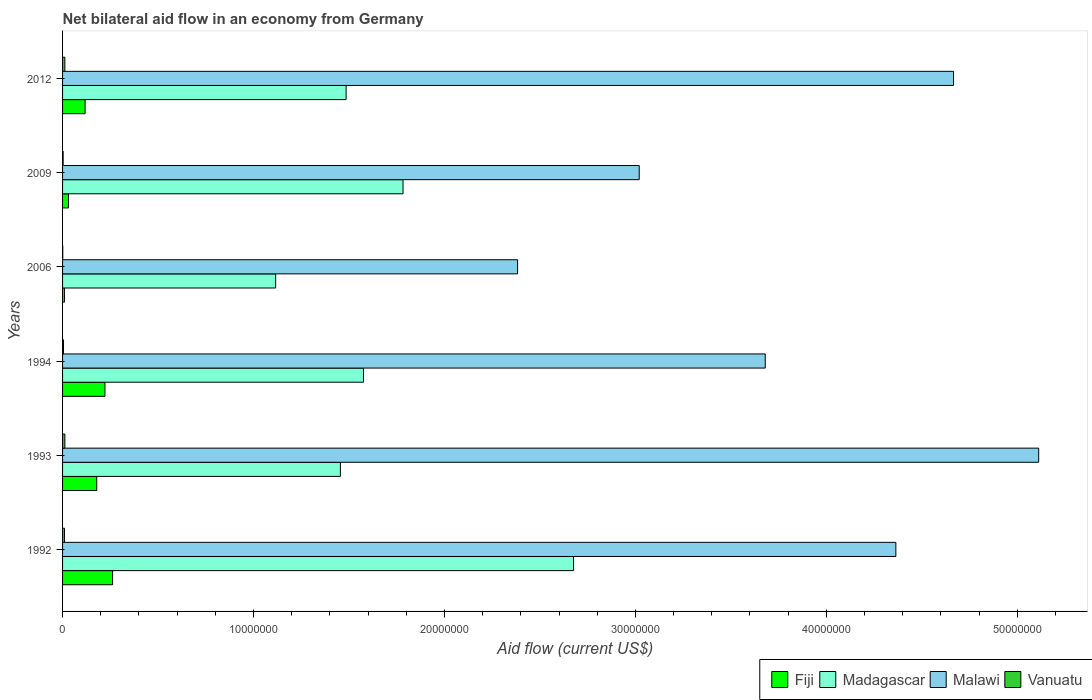How many different coloured bars are there?
Your answer should be compact. 4. How many bars are there on the 3rd tick from the bottom?
Your answer should be compact. 4. What is the net bilateral aid flow in Malawi in 1993?
Your response must be concise. 5.11e+07. Across all years, what is the maximum net bilateral aid flow in Vanuatu?
Keep it short and to the point. 1.20e+05. Across all years, what is the minimum net bilateral aid flow in Fiji?
Your response must be concise. 1.00e+05. In which year was the net bilateral aid flow in Fiji minimum?
Your answer should be very brief. 2006. What is the total net bilateral aid flow in Madagascar in the graph?
Give a very brief answer. 1.01e+08. What is the difference between the net bilateral aid flow in Madagascar in 1992 and that in 2006?
Make the answer very short. 1.56e+07. What is the difference between the net bilateral aid flow in Malawi in 2006 and the net bilateral aid flow in Fiji in 1994?
Ensure brevity in your answer.  2.16e+07. What is the average net bilateral aid flow in Malawi per year?
Your answer should be compact. 3.87e+07. In the year 1993, what is the difference between the net bilateral aid flow in Malawi and net bilateral aid flow in Vanuatu?
Your response must be concise. 5.10e+07. What is the ratio of the net bilateral aid flow in Fiji in 1993 to that in 2012?
Provide a short and direct response. 1.52. What is the difference between the highest and the lowest net bilateral aid flow in Malawi?
Provide a succinct answer. 2.73e+07. In how many years, is the net bilateral aid flow in Madagascar greater than the average net bilateral aid flow in Madagascar taken over all years?
Offer a very short reply. 2. What does the 2nd bar from the top in 2009 represents?
Offer a very short reply. Malawi. What does the 4th bar from the bottom in 1993 represents?
Provide a succinct answer. Vanuatu. How many bars are there?
Keep it short and to the point. 24. Are all the bars in the graph horizontal?
Offer a very short reply. Yes. Are the values on the major ticks of X-axis written in scientific E-notation?
Give a very brief answer. No. Does the graph contain grids?
Your answer should be very brief. No. Where does the legend appear in the graph?
Your answer should be compact. Bottom right. How many legend labels are there?
Provide a succinct answer. 4. What is the title of the graph?
Ensure brevity in your answer.  Net bilateral aid flow in an economy from Germany. Does "Zambia" appear as one of the legend labels in the graph?
Offer a very short reply. No. What is the label or title of the Y-axis?
Keep it short and to the point. Years. What is the Aid flow (current US$) in Fiji in 1992?
Make the answer very short. 2.62e+06. What is the Aid flow (current US$) of Madagascar in 1992?
Your response must be concise. 2.68e+07. What is the Aid flow (current US$) of Malawi in 1992?
Keep it short and to the point. 4.36e+07. What is the Aid flow (current US$) of Vanuatu in 1992?
Keep it short and to the point. 1.00e+05. What is the Aid flow (current US$) of Fiji in 1993?
Your response must be concise. 1.79e+06. What is the Aid flow (current US$) in Madagascar in 1993?
Your answer should be very brief. 1.46e+07. What is the Aid flow (current US$) in Malawi in 1993?
Make the answer very short. 5.11e+07. What is the Aid flow (current US$) of Fiji in 1994?
Give a very brief answer. 2.22e+06. What is the Aid flow (current US$) of Madagascar in 1994?
Make the answer very short. 1.58e+07. What is the Aid flow (current US$) of Malawi in 1994?
Make the answer very short. 3.68e+07. What is the Aid flow (current US$) of Vanuatu in 1994?
Your answer should be compact. 5.00e+04. What is the Aid flow (current US$) of Fiji in 2006?
Offer a terse response. 1.00e+05. What is the Aid flow (current US$) of Madagascar in 2006?
Provide a succinct answer. 1.12e+07. What is the Aid flow (current US$) in Malawi in 2006?
Keep it short and to the point. 2.38e+07. What is the Aid flow (current US$) in Vanuatu in 2006?
Make the answer very short. 10000. What is the Aid flow (current US$) of Fiji in 2009?
Offer a very short reply. 3.10e+05. What is the Aid flow (current US$) of Madagascar in 2009?
Provide a succinct answer. 1.78e+07. What is the Aid flow (current US$) in Malawi in 2009?
Give a very brief answer. 3.02e+07. What is the Aid flow (current US$) of Fiji in 2012?
Offer a terse response. 1.18e+06. What is the Aid flow (current US$) in Madagascar in 2012?
Your response must be concise. 1.48e+07. What is the Aid flow (current US$) in Malawi in 2012?
Make the answer very short. 4.67e+07. Across all years, what is the maximum Aid flow (current US$) in Fiji?
Provide a short and direct response. 2.62e+06. Across all years, what is the maximum Aid flow (current US$) in Madagascar?
Offer a terse response. 2.68e+07. Across all years, what is the maximum Aid flow (current US$) in Malawi?
Provide a succinct answer. 5.11e+07. Across all years, what is the maximum Aid flow (current US$) of Vanuatu?
Provide a short and direct response. 1.20e+05. Across all years, what is the minimum Aid flow (current US$) of Madagascar?
Keep it short and to the point. 1.12e+07. Across all years, what is the minimum Aid flow (current US$) of Malawi?
Provide a short and direct response. 2.38e+07. Across all years, what is the minimum Aid flow (current US$) in Vanuatu?
Provide a succinct answer. 10000. What is the total Aid flow (current US$) of Fiji in the graph?
Your answer should be compact. 8.22e+06. What is the total Aid flow (current US$) of Madagascar in the graph?
Offer a very short reply. 1.01e+08. What is the total Aid flow (current US$) of Malawi in the graph?
Your answer should be compact. 2.32e+08. What is the total Aid flow (current US$) in Vanuatu in the graph?
Ensure brevity in your answer.  4.30e+05. What is the difference between the Aid flow (current US$) of Fiji in 1992 and that in 1993?
Provide a short and direct response. 8.30e+05. What is the difference between the Aid flow (current US$) in Madagascar in 1992 and that in 1993?
Provide a succinct answer. 1.22e+07. What is the difference between the Aid flow (current US$) of Malawi in 1992 and that in 1993?
Provide a short and direct response. -7.48e+06. What is the difference between the Aid flow (current US$) of Vanuatu in 1992 and that in 1993?
Your answer should be compact. -2.00e+04. What is the difference between the Aid flow (current US$) of Fiji in 1992 and that in 1994?
Provide a succinct answer. 4.00e+05. What is the difference between the Aid flow (current US$) in Madagascar in 1992 and that in 1994?
Make the answer very short. 1.10e+07. What is the difference between the Aid flow (current US$) in Malawi in 1992 and that in 1994?
Provide a succinct answer. 6.84e+06. What is the difference between the Aid flow (current US$) of Vanuatu in 1992 and that in 1994?
Provide a succinct answer. 5.00e+04. What is the difference between the Aid flow (current US$) in Fiji in 1992 and that in 2006?
Give a very brief answer. 2.52e+06. What is the difference between the Aid flow (current US$) of Madagascar in 1992 and that in 2006?
Offer a terse response. 1.56e+07. What is the difference between the Aid flow (current US$) in Malawi in 1992 and that in 2006?
Your answer should be compact. 1.98e+07. What is the difference between the Aid flow (current US$) of Fiji in 1992 and that in 2009?
Your answer should be very brief. 2.31e+06. What is the difference between the Aid flow (current US$) in Madagascar in 1992 and that in 2009?
Your answer should be compact. 8.93e+06. What is the difference between the Aid flow (current US$) in Malawi in 1992 and that in 2009?
Ensure brevity in your answer.  1.34e+07. What is the difference between the Aid flow (current US$) in Vanuatu in 1992 and that in 2009?
Give a very brief answer. 7.00e+04. What is the difference between the Aid flow (current US$) in Fiji in 1992 and that in 2012?
Provide a short and direct response. 1.44e+06. What is the difference between the Aid flow (current US$) in Madagascar in 1992 and that in 2012?
Provide a succinct answer. 1.19e+07. What is the difference between the Aid flow (current US$) of Malawi in 1992 and that in 2012?
Offer a terse response. -3.02e+06. What is the difference between the Aid flow (current US$) in Fiji in 1993 and that in 1994?
Make the answer very short. -4.30e+05. What is the difference between the Aid flow (current US$) in Madagascar in 1993 and that in 1994?
Provide a short and direct response. -1.21e+06. What is the difference between the Aid flow (current US$) of Malawi in 1993 and that in 1994?
Keep it short and to the point. 1.43e+07. What is the difference between the Aid flow (current US$) of Vanuatu in 1993 and that in 1994?
Give a very brief answer. 7.00e+04. What is the difference between the Aid flow (current US$) in Fiji in 1993 and that in 2006?
Your response must be concise. 1.69e+06. What is the difference between the Aid flow (current US$) of Madagascar in 1993 and that in 2006?
Ensure brevity in your answer.  3.39e+06. What is the difference between the Aid flow (current US$) of Malawi in 1993 and that in 2006?
Your response must be concise. 2.73e+07. What is the difference between the Aid flow (current US$) of Vanuatu in 1993 and that in 2006?
Ensure brevity in your answer.  1.10e+05. What is the difference between the Aid flow (current US$) of Fiji in 1993 and that in 2009?
Your answer should be compact. 1.48e+06. What is the difference between the Aid flow (current US$) in Madagascar in 1993 and that in 2009?
Give a very brief answer. -3.28e+06. What is the difference between the Aid flow (current US$) in Malawi in 1993 and that in 2009?
Ensure brevity in your answer.  2.09e+07. What is the difference between the Aid flow (current US$) in Fiji in 1993 and that in 2012?
Provide a short and direct response. 6.10e+05. What is the difference between the Aid flow (current US$) of Malawi in 1993 and that in 2012?
Your answer should be very brief. 4.46e+06. What is the difference between the Aid flow (current US$) of Vanuatu in 1993 and that in 2012?
Provide a short and direct response. 0. What is the difference between the Aid flow (current US$) of Fiji in 1994 and that in 2006?
Make the answer very short. 2.12e+06. What is the difference between the Aid flow (current US$) of Madagascar in 1994 and that in 2006?
Your answer should be compact. 4.60e+06. What is the difference between the Aid flow (current US$) of Malawi in 1994 and that in 2006?
Keep it short and to the point. 1.30e+07. What is the difference between the Aid flow (current US$) in Vanuatu in 1994 and that in 2006?
Ensure brevity in your answer.  4.00e+04. What is the difference between the Aid flow (current US$) in Fiji in 1994 and that in 2009?
Provide a short and direct response. 1.91e+06. What is the difference between the Aid flow (current US$) in Madagascar in 1994 and that in 2009?
Give a very brief answer. -2.07e+06. What is the difference between the Aid flow (current US$) in Malawi in 1994 and that in 2009?
Keep it short and to the point. 6.60e+06. What is the difference between the Aid flow (current US$) of Vanuatu in 1994 and that in 2009?
Offer a very short reply. 2.00e+04. What is the difference between the Aid flow (current US$) of Fiji in 1994 and that in 2012?
Your response must be concise. 1.04e+06. What is the difference between the Aid flow (current US$) in Madagascar in 1994 and that in 2012?
Your answer should be compact. 9.10e+05. What is the difference between the Aid flow (current US$) of Malawi in 1994 and that in 2012?
Keep it short and to the point. -9.86e+06. What is the difference between the Aid flow (current US$) in Vanuatu in 1994 and that in 2012?
Provide a succinct answer. -7.00e+04. What is the difference between the Aid flow (current US$) of Madagascar in 2006 and that in 2009?
Make the answer very short. -6.67e+06. What is the difference between the Aid flow (current US$) of Malawi in 2006 and that in 2009?
Provide a short and direct response. -6.37e+06. What is the difference between the Aid flow (current US$) in Vanuatu in 2006 and that in 2009?
Make the answer very short. -2.00e+04. What is the difference between the Aid flow (current US$) in Fiji in 2006 and that in 2012?
Ensure brevity in your answer.  -1.08e+06. What is the difference between the Aid flow (current US$) of Madagascar in 2006 and that in 2012?
Your answer should be compact. -3.69e+06. What is the difference between the Aid flow (current US$) of Malawi in 2006 and that in 2012?
Ensure brevity in your answer.  -2.28e+07. What is the difference between the Aid flow (current US$) in Vanuatu in 2006 and that in 2012?
Give a very brief answer. -1.10e+05. What is the difference between the Aid flow (current US$) of Fiji in 2009 and that in 2012?
Give a very brief answer. -8.70e+05. What is the difference between the Aid flow (current US$) of Madagascar in 2009 and that in 2012?
Provide a succinct answer. 2.98e+06. What is the difference between the Aid flow (current US$) in Malawi in 2009 and that in 2012?
Your response must be concise. -1.65e+07. What is the difference between the Aid flow (current US$) of Vanuatu in 2009 and that in 2012?
Your answer should be compact. -9.00e+04. What is the difference between the Aid flow (current US$) in Fiji in 1992 and the Aid flow (current US$) in Madagascar in 1993?
Provide a succinct answer. -1.19e+07. What is the difference between the Aid flow (current US$) of Fiji in 1992 and the Aid flow (current US$) of Malawi in 1993?
Your answer should be very brief. -4.85e+07. What is the difference between the Aid flow (current US$) of Fiji in 1992 and the Aid flow (current US$) of Vanuatu in 1993?
Your answer should be compact. 2.50e+06. What is the difference between the Aid flow (current US$) in Madagascar in 1992 and the Aid flow (current US$) in Malawi in 1993?
Make the answer very short. -2.44e+07. What is the difference between the Aid flow (current US$) in Madagascar in 1992 and the Aid flow (current US$) in Vanuatu in 1993?
Ensure brevity in your answer.  2.66e+07. What is the difference between the Aid flow (current US$) in Malawi in 1992 and the Aid flow (current US$) in Vanuatu in 1993?
Offer a terse response. 4.35e+07. What is the difference between the Aid flow (current US$) in Fiji in 1992 and the Aid flow (current US$) in Madagascar in 1994?
Your answer should be very brief. -1.31e+07. What is the difference between the Aid flow (current US$) in Fiji in 1992 and the Aid flow (current US$) in Malawi in 1994?
Provide a short and direct response. -3.42e+07. What is the difference between the Aid flow (current US$) of Fiji in 1992 and the Aid flow (current US$) of Vanuatu in 1994?
Your answer should be very brief. 2.57e+06. What is the difference between the Aid flow (current US$) in Madagascar in 1992 and the Aid flow (current US$) in Malawi in 1994?
Ensure brevity in your answer.  -1.00e+07. What is the difference between the Aid flow (current US$) of Madagascar in 1992 and the Aid flow (current US$) of Vanuatu in 1994?
Provide a succinct answer. 2.67e+07. What is the difference between the Aid flow (current US$) in Malawi in 1992 and the Aid flow (current US$) in Vanuatu in 1994?
Your response must be concise. 4.36e+07. What is the difference between the Aid flow (current US$) in Fiji in 1992 and the Aid flow (current US$) in Madagascar in 2006?
Your answer should be very brief. -8.54e+06. What is the difference between the Aid flow (current US$) in Fiji in 1992 and the Aid flow (current US$) in Malawi in 2006?
Provide a succinct answer. -2.12e+07. What is the difference between the Aid flow (current US$) in Fiji in 1992 and the Aid flow (current US$) in Vanuatu in 2006?
Your answer should be very brief. 2.61e+06. What is the difference between the Aid flow (current US$) of Madagascar in 1992 and the Aid flow (current US$) of Malawi in 2006?
Offer a terse response. 2.93e+06. What is the difference between the Aid flow (current US$) of Madagascar in 1992 and the Aid flow (current US$) of Vanuatu in 2006?
Your answer should be compact. 2.68e+07. What is the difference between the Aid flow (current US$) in Malawi in 1992 and the Aid flow (current US$) in Vanuatu in 2006?
Make the answer very short. 4.36e+07. What is the difference between the Aid flow (current US$) of Fiji in 1992 and the Aid flow (current US$) of Madagascar in 2009?
Make the answer very short. -1.52e+07. What is the difference between the Aid flow (current US$) in Fiji in 1992 and the Aid flow (current US$) in Malawi in 2009?
Your response must be concise. -2.76e+07. What is the difference between the Aid flow (current US$) of Fiji in 1992 and the Aid flow (current US$) of Vanuatu in 2009?
Offer a very short reply. 2.59e+06. What is the difference between the Aid flow (current US$) of Madagascar in 1992 and the Aid flow (current US$) of Malawi in 2009?
Your answer should be compact. -3.44e+06. What is the difference between the Aid flow (current US$) of Madagascar in 1992 and the Aid flow (current US$) of Vanuatu in 2009?
Provide a short and direct response. 2.67e+07. What is the difference between the Aid flow (current US$) in Malawi in 1992 and the Aid flow (current US$) in Vanuatu in 2009?
Keep it short and to the point. 4.36e+07. What is the difference between the Aid flow (current US$) in Fiji in 1992 and the Aid flow (current US$) in Madagascar in 2012?
Your response must be concise. -1.22e+07. What is the difference between the Aid flow (current US$) in Fiji in 1992 and the Aid flow (current US$) in Malawi in 2012?
Your answer should be compact. -4.40e+07. What is the difference between the Aid flow (current US$) in Fiji in 1992 and the Aid flow (current US$) in Vanuatu in 2012?
Ensure brevity in your answer.  2.50e+06. What is the difference between the Aid flow (current US$) of Madagascar in 1992 and the Aid flow (current US$) of Malawi in 2012?
Your answer should be compact. -1.99e+07. What is the difference between the Aid flow (current US$) of Madagascar in 1992 and the Aid flow (current US$) of Vanuatu in 2012?
Give a very brief answer. 2.66e+07. What is the difference between the Aid flow (current US$) in Malawi in 1992 and the Aid flow (current US$) in Vanuatu in 2012?
Provide a short and direct response. 4.35e+07. What is the difference between the Aid flow (current US$) in Fiji in 1993 and the Aid flow (current US$) in Madagascar in 1994?
Offer a terse response. -1.40e+07. What is the difference between the Aid flow (current US$) in Fiji in 1993 and the Aid flow (current US$) in Malawi in 1994?
Ensure brevity in your answer.  -3.50e+07. What is the difference between the Aid flow (current US$) in Fiji in 1993 and the Aid flow (current US$) in Vanuatu in 1994?
Provide a short and direct response. 1.74e+06. What is the difference between the Aid flow (current US$) in Madagascar in 1993 and the Aid flow (current US$) in Malawi in 1994?
Offer a very short reply. -2.22e+07. What is the difference between the Aid flow (current US$) of Madagascar in 1993 and the Aid flow (current US$) of Vanuatu in 1994?
Offer a very short reply. 1.45e+07. What is the difference between the Aid flow (current US$) in Malawi in 1993 and the Aid flow (current US$) in Vanuatu in 1994?
Ensure brevity in your answer.  5.11e+07. What is the difference between the Aid flow (current US$) in Fiji in 1993 and the Aid flow (current US$) in Madagascar in 2006?
Keep it short and to the point. -9.37e+06. What is the difference between the Aid flow (current US$) in Fiji in 1993 and the Aid flow (current US$) in Malawi in 2006?
Your response must be concise. -2.20e+07. What is the difference between the Aid flow (current US$) of Fiji in 1993 and the Aid flow (current US$) of Vanuatu in 2006?
Provide a short and direct response. 1.78e+06. What is the difference between the Aid flow (current US$) of Madagascar in 1993 and the Aid flow (current US$) of Malawi in 2006?
Make the answer very short. -9.28e+06. What is the difference between the Aid flow (current US$) in Madagascar in 1993 and the Aid flow (current US$) in Vanuatu in 2006?
Provide a succinct answer. 1.45e+07. What is the difference between the Aid flow (current US$) in Malawi in 1993 and the Aid flow (current US$) in Vanuatu in 2006?
Keep it short and to the point. 5.11e+07. What is the difference between the Aid flow (current US$) in Fiji in 1993 and the Aid flow (current US$) in Madagascar in 2009?
Offer a very short reply. -1.60e+07. What is the difference between the Aid flow (current US$) of Fiji in 1993 and the Aid flow (current US$) of Malawi in 2009?
Your answer should be compact. -2.84e+07. What is the difference between the Aid flow (current US$) of Fiji in 1993 and the Aid flow (current US$) of Vanuatu in 2009?
Your answer should be compact. 1.76e+06. What is the difference between the Aid flow (current US$) of Madagascar in 1993 and the Aid flow (current US$) of Malawi in 2009?
Your answer should be very brief. -1.56e+07. What is the difference between the Aid flow (current US$) in Madagascar in 1993 and the Aid flow (current US$) in Vanuatu in 2009?
Make the answer very short. 1.45e+07. What is the difference between the Aid flow (current US$) of Malawi in 1993 and the Aid flow (current US$) of Vanuatu in 2009?
Offer a terse response. 5.11e+07. What is the difference between the Aid flow (current US$) of Fiji in 1993 and the Aid flow (current US$) of Madagascar in 2012?
Your answer should be very brief. -1.31e+07. What is the difference between the Aid flow (current US$) in Fiji in 1993 and the Aid flow (current US$) in Malawi in 2012?
Your answer should be compact. -4.49e+07. What is the difference between the Aid flow (current US$) of Fiji in 1993 and the Aid flow (current US$) of Vanuatu in 2012?
Keep it short and to the point. 1.67e+06. What is the difference between the Aid flow (current US$) in Madagascar in 1993 and the Aid flow (current US$) in Malawi in 2012?
Make the answer very short. -3.21e+07. What is the difference between the Aid flow (current US$) in Madagascar in 1993 and the Aid flow (current US$) in Vanuatu in 2012?
Offer a very short reply. 1.44e+07. What is the difference between the Aid flow (current US$) in Malawi in 1993 and the Aid flow (current US$) in Vanuatu in 2012?
Provide a succinct answer. 5.10e+07. What is the difference between the Aid flow (current US$) in Fiji in 1994 and the Aid flow (current US$) in Madagascar in 2006?
Make the answer very short. -8.94e+06. What is the difference between the Aid flow (current US$) in Fiji in 1994 and the Aid flow (current US$) in Malawi in 2006?
Ensure brevity in your answer.  -2.16e+07. What is the difference between the Aid flow (current US$) in Fiji in 1994 and the Aid flow (current US$) in Vanuatu in 2006?
Keep it short and to the point. 2.21e+06. What is the difference between the Aid flow (current US$) of Madagascar in 1994 and the Aid flow (current US$) of Malawi in 2006?
Give a very brief answer. -8.07e+06. What is the difference between the Aid flow (current US$) of Madagascar in 1994 and the Aid flow (current US$) of Vanuatu in 2006?
Keep it short and to the point. 1.58e+07. What is the difference between the Aid flow (current US$) in Malawi in 1994 and the Aid flow (current US$) in Vanuatu in 2006?
Offer a terse response. 3.68e+07. What is the difference between the Aid flow (current US$) of Fiji in 1994 and the Aid flow (current US$) of Madagascar in 2009?
Your response must be concise. -1.56e+07. What is the difference between the Aid flow (current US$) of Fiji in 1994 and the Aid flow (current US$) of Malawi in 2009?
Your response must be concise. -2.80e+07. What is the difference between the Aid flow (current US$) in Fiji in 1994 and the Aid flow (current US$) in Vanuatu in 2009?
Offer a terse response. 2.19e+06. What is the difference between the Aid flow (current US$) in Madagascar in 1994 and the Aid flow (current US$) in Malawi in 2009?
Keep it short and to the point. -1.44e+07. What is the difference between the Aid flow (current US$) in Madagascar in 1994 and the Aid flow (current US$) in Vanuatu in 2009?
Provide a succinct answer. 1.57e+07. What is the difference between the Aid flow (current US$) in Malawi in 1994 and the Aid flow (current US$) in Vanuatu in 2009?
Your response must be concise. 3.68e+07. What is the difference between the Aid flow (current US$) of Fiji in 1994 and the Aid flow (current US$) of Madagascar in 2012?
Your answer should be compact. -1.26e+07. What is the difference between the Aid flow (current US$) of Fiji in 1994 and the Aid flow (current US$) of Malawi in 2012?
Your response must be concise. -4.44e+07. What is the difference between the Aid flow (current US$) of Fiji in 1994 and the Aid flow (current US$) of Vanuatu in 2012?
Keep it short and to the point. 2.10e+06. What is the difference between the Aid flow (current US$) of Madagascar in 1994 and the Aid flow (current US$) of Malawi in 2012?
Provide a short and direct response. -3.09e+07. What is the difference between the Aid flow (current US$) in Madagascar in 1994 and the Aid flow (current US$) in Vanuatu in 2012?
Your answer should be compact. 1.56e+07. What is the difference between the Aid flow (current US$) in Malawi in 1994 and the Aid flow (current US$) in Vanuatu in 2012?
Provide a short and direct response. 3.67e+07. What is the difference between the Aid flow (current US$) of Fiji in 2006 and the Aid flow (current US$) of Madagascar in 2009?
Provide a succinct answer. -1.77e+07. What is the difference between the Aid flow (current US$) of Fiji in 2006 and the Aid flow (current US$) of Malawi in 2009?
Provide a short and direct response. -3.01e+07. What is the difference between the Aid flow (current US$) of Fiji in 2006 and the Aid flow (current US$) of Vanuatu in 2009?
Offer a very short reply. 7.00e+04. What is the difference between the Aid flow (current US$) of Madagascar in 2006 and the Aid flow (current US$) of Malawi in 2009?
Keep it short and to the point. -1.90e+07. What is the difference between the Aid flow (current US$) in Madagascar in 2006 and the Aid flow (current US$) in Vanuatu in 2009?
Ensure brevity in your answer.  1.11e+07. What is the difference between the Aid flow (current US$) of Malawi in 2006 and the Aid flow (current US$) of Vanuatu in 2009?
Your answer should be compact. 2.38e+07. What is the difference between the Aid flow (current US$) in Fiji in 2006 and the Aid flow (current US$) in Madagascar in 2012?
Your answer should be very brief. -1.48e+07. What is the difference between the Aid flow (current US$) of Fiji in 2006 and the Aid flow (current US$) of Malawi in 2012?
Your answer should be very brief. -4.66e+07. What is the difference between the Aid flow (current US$) in Fiji in 2006 and the Aid flow (current US$) in Vanuatu in 2012?
Ensure brevity in your answer.  -2.00e+04. What is the difference between the Aid flow (current US$) of Madagascar in 2006 and the Aid flow (current US$) of Malawi in 2012?
Make the answer very short. -3.55e+07. What is the difference between the Aid flow (current US$) of Madagascar in 2006 and the Aid flow (current US$) of Vanuatu in 2012?
Give a very brief answer. 1.10e+07. What is the difference between the Aid flow (current US$) of Malawi in 2006 and the Aid flow (current US$) of Vanuatu in 2012?
Ensure brevity in your answer.  2.37e+07. What is the difference between the Aid flow (current US$) of Fiji in 2009 and the Aid flow (current US$) of Madagascar in 2012?
Make the answer very short. -1.45e+07. What is the difference between the Aid flow (current US$) of Fiji in 2009 and the Aid flow (current US$) of Malawi in 2012?
Your response must be concise. -4.64e+07. What is the difference between the Aid flow (current US$) in Madagascar in 2009 and the Aid flow (current US$) in Malawi in 2012?
Your response must be concise. -2.88e+07. What is the difference between the Aid flow (current US$) of Madagascar in 2009 and the Aid flow (current US$) of Vanuatu in 2012?
Give a very brief answer. 1.77e+07. What is the difference between the Aid flow (current US$) in Malawi in 2009 and the Aid flow (current US$) in Vanuatu in 2012?
Your answer should be very brief. 3.01e+07. What is the average Aid flow (current US$) of Fiji per year?
Ensure brevity in your answer.  1.37e+06. What is the average Aid flow (current US$) in Madagascar per year?
Offer a very short reply. 1.68e+07. What is the average Aid flow (current US$) in Malawi per year?
Your response must be concise. 3.87e+07. What is the average Aid flow (current US$) in Vanuatu per year?
Provide a short and direct response. 7.17e+04. In the year 1992, what is the difference between the Aid flow (current US$) in Fiji and Aid flow (current US$) in Madagascar?
Offer a terse response. -2.41e+07. In the year 1992, what is the difference between the Aid flow (current US$) of Fiji and Aid flow (current US$) of Malawi?
Your answer should be very brief. -4.10e+07. In the year 1992, what is the difference between the Aid flow (current US$) in Fiji and Aid flow (current US$) in Vanuatu?
Ensure brevity in your answer.  2.52e+06. In the year 1992, what is the difference between the Aid flow (current US$) in Madagascar and Aid flow (current US$) in Malawi?
Make the answer very short. -1.69e+07. In the year 1992, what is the difference between the Aid flow (current US$) in Madagascar and Aid flow (current US$) in Vanuatu?
Give a very brief answer. 2.67e+07. In the year 1992, what is the difference between the Aid flow (current US$) in Malawi and Aid flow (current US$) in Vanuatu?
Your response must be concise. 4.35e+07. In the year 1993, what is the difference between the Aid flow (current US$) in Fiji and Aid flow (current US$) in Madagascar?
Your response must be concise. -1.28e+07. In the year 1993, what is the difference between the Aid flow (current US$) in Fiji and Aid flow (current US$) in Malawi?
Offer a terse response. -4.93e+07. In the year 1993, what is the difference between the Aid flow (current US$) of Fiji and Aid flow (current US$) of Vanuatu?
Provide a short and direct response. 1.67e+06. In the year 1993, what is the difference between the Aid flow (current US$) of Madagascar and Aid flow (current US$) of Malawi?
Give a very brief answer. -3.66e+07. In the year 1993, what is the difference between the Aid flow (current US$) in Madagascar and Aid flow (current US$) in Vanuatu?
Provide a succinct answer. 1.44e+07. In the year 1993, what is the difference between the Aid flow (current US$) in Malawi and Aid flow (current US$) in Vanuatu?
Make the answer very short. 5.10e+07. In the year 1994, what is the difference between the Aid flow (current US$) of Fiji and Aid flow (current US$) of Madagascar?
Give a very brief answer. -1.35e+07. In the year 1994, what is the difference between the Aid flow (current US$) in Fiji and Aid flow (current US$) in Malawi?
Your answer should be compact. -3.46e+07. In the year 1994, what is the difference between the Aid flow (current US$) of Fiji and Aid flow (current US$) of Vanuatu?
Your answer should be very brief. 2.17e+06. In the year 1994, what is the difference between the Aid flow (current US$) in Madagascar and Aid flow (current US$) in Malawi?
Make the answer very short. -2.10e+07. In the year 1994, what is the difference between the Aid flow (current US$) in Madagascar and Aid flow (current US$) in Vanuatu?
Provide a succinct answer. 1.57e+07. In the year 1994, what is the difference between the Aid flow (current US$) in Malawi and Aid flow (current US$) in Vanuatu?
Make the answer very short. 3.68e+07. In the year 2006, what is the difference between the Aid flow (current US$) in Fiji and Aid flow (current US$) in Madagascar?
Provide a succinct answer. -1.11e+07. In the year 2006, what is the difference between the Aid flow (current US$) of Fiji and Aid flow (current US$) of Malawi?
Provide a short and direct response. -2.37e+07. In the year 2006, what is the difference between the Aid flow (current US$) of Fiji and Aid flow (current US$) of Vanuatu?
Your answer should be compact. 9.00e+04. In the year 2006, what is the difference between the Aid flow (current US$) of Madagascar and Aid flow (current US$) of Malawi?
Provide a short and direct response. -1.27e+07. In the year 2006, what is the difference between the Aid flow (current US$) in Madagascar and Aid flow (current US$) in Vanuatu?
Offer a terse response. 1.12e+07. In the year 2006, what is the difference between the Aid flow (current US$) of Malawi and Aid flow (current US$) of Vanuatu?
Offer a very short reply. 2.38e+07. In the year 2009, what is the difference between the Aid flow (current US$) in Fiji and Aid flow (current US$) in Madagascar?
Provide a short and direct response. -1.75e+07. In the year 2009, what is the difference between the Aid flow (current US$) in Fiji and Aid flow (current US$) in Malawi?
Keep it short and to the point. -2.99e+07. In the year 2009, what is the difference between the Aid flow (current US$) in Fiji and Aid flow (current US$) in Vanuatu?
Your answer should be compact. 2.80e+05. In the year 2009, what is the difference between the Aid flow (current US$) of Madagascar and Aid flow (current US$) of Malawi?
Your response must be concise. -1.24e+07. In the year 2009, what is the difference between the Aid flow (current US$) of Madagascar and Aid flow (current US$) of Vanuatu?
Offer a very short reply. 1.78e+07. In the year 2009, what is the difference between the Aid flow (current US$) in Malawi and Aid flow (current US$) in Vanuatu?
Ensure brevity in your answer.  3.02e+07. In the year 2012, what is the difference between the Aid flow (current US$) of Fiji and Aid flow (current US$) of Madagascar?
Provide a short and direct response. -1.37e+07. In the year 2012, what is the difference between the Aid flow (current US$) in Fiji and Aid flow (current US$) in Malawi?
Provide a succinct answer. -4.55e+07. In the year 2012, what is the difference between the Aid flow (current US$) of Fiji and Aid flow (current US$) of Vanuatu?
Your answer should be compact. 1.06e+06. In the year 2012, what is the difference between the Aid flow (current US$) in Madagascar and Aid flow (current US$) in Malawi?
Make the answer very short. -3.18e+07. In the year 2012, what is the difference between the Aid flow (current US$) in Madagascar and Aid flow (current US$) in Vanuatu?
Make the answer very short. 1.47e+07. In the year 2012, what is the difference between the Aid flow (current US$) in Malawi and Aid flow (current US$) in Vanuatu?
Your answer should be compact. 4.65e+07. What is the ratio of the Aid flow (current US$) of Fiji in 1992 to that in 1993?
Give a very brief answer. 1.46. What is the ratio of the Aid flow (current US$) in Madagascar in 1992 to that in 1993?
Provide a succinct answer. 1.84. What is the ratio of the Aid flow (current US$) of Malawi in 1992 to that in 1993?
Your response must be concise. 0.85. What is the ratio of the Aid flow (current US$) of Fiji in 1992 to that in 1994?
Your response must be concise. 1.18. What is the ratio of the Aid flow (current US$) in Madagascar in 1992 to that in 1994?
Offer a very short reply. 1.7. What is the ratio of the Aid flow (current US$) in Malawi in 1992 to that in 1994?
Your answer should be compact. 1.19. What is the ratio of the Aid flow (current US$) of Fiji in 1992 to that in 2006?
Provide a succinct answer. 26.2. What is the ratio of the Aid flow (current US$) in Madagascar in 1992 to that in 2006?
Provide a short and direct response. 2.4. What is the ratio of the Aid flow (current US$) of Malawi in 1992 to that in 2006?
Provide a succinct answer. 1.83. What is the ratio of the Aid flow (current US$) of Vanuatu in 1992 to that in 2006?
Offer a terse response. 10. What is the ratio of the Aid flow (current US$) in Fiji in 1992 to that in 2009?
Your answer should be compact. 8.45. What is the ratio of the Aid flow (current US$) of Madagascar in 1992 to that in 2009?
Ensure brevity in your answer.  1.5. What is the ratio of the Aid flow (current US$) in Malawi in 1992 to that in 2009?
Ensure brevity in your answer.  1.45. What is the ratio of the Aid flow (current US$) of Fiji in 1992 to that in 2012?
Ensure brevity in your answer.  2.22. What is the ratio of the Aid flow (current US$) of Madagascar in 1992 to that in 2012?
Provide a succinct answer. 1.8. What is the ratio of the Aid flow (current US$) of Malawi in 1992 to that in 2012?
Keep it short and to the point. 0.94. What is the ratio of the Aid flow (current US$) of Fiji in 1993 to that in 1994?
Offer a very short reply. 0.81. What is the ratio of the Aid flow (current US$) in Madagascar in 1993 to that in 1994?
Give a very brief answer. 0.92. What is the ratio of the Aid flow (current US$) in Malawi in 1993 to that in 1994?
Keep it short and to the point. 1.39. What is the ratio of the Aid flow (current US$) in Madagascar in 1993 to that in 2006?
Provide a succinct answer. 1.3. What is the ratio of the Aid flow (current US$) in Malawi in 1993 to that in 2006?
Ensure brevity in your answer.  2.15. What is the ratio of the Aid flow (current US$) of Fiji in 1993 to that in 2009?
Offer a terse response. 5.77. What is the ratio of the Aid flow (current US$) in Madagascar in 1993 to that in 2009?
Provide a succinct answer. 0.82. What is the ratio of the Aid flow (current US$) in Malawi in 1993 to that in 2009?
Your answer should be compact. 1.69. What is the ratio of the Aid flow (current US$) in Fiji in 1993 to that in 2012?
Offer a terse response. 1.52. What is the ratio of the Aid flow (current US$) in Madagascar in 1993 to that in 2012?
Offer a terse response. 0.98. What is the ratio of the Aid flow (current US$) in Malawi in 1993 to that in 2012?
Provide a short and direct response. 1.1. What is the ratio of the Aid flow (current US$) in Fiji in 1994 to that in 2006?
Your response must be concise. 22.2. What is the ratio of the Aid flow (current US$) in Madagascar in 1994 to that in 2006?
Your answer should be compact. 1.41. What is the ratio of the Aid flow (current US$) of Malawi in 1994 to that in 2006?
Offer a very short reply. 1.54. What is the ratio of the Aid flow (current US$) of Fiji in 1994 to that in 2009?
Offer a very short reply. 7.16. What is the ratio of the Aid flow (current US$) in Madagascar in 1994 to that in 2009?
Ensure brevity in your answer.  0.88. What is the ratio of the Aid flow (current US$) of Malawi in 1994 to that in 2009?
Provide a succinct answer. 1.22. What is the ratio of the Aid flow (current US$) in Fiji in 1994 to that in 2012?
Make the answer very short. 1.88. What is the ratio of the Aid flow (current US$) of Madagascar in 1994 to that in 2012?
Give a very brief answer. 1.06. What is the ratio of the Aid flow (current US$) of Malawi in 1994 to that in 2012?
Keep it short and to the point. 0.79. What is the ratio of the Aid flow (current US$) of Vanuatu in 1994 to that in 2012?
Give a very brief answer. 0.42. What is the ratio of the Aid flow (current US$) in Fiji in 2006 to that in 2009?
Provide a succinct answer. 0.32. What is the ratio of the Aid flow (current US$) in Madagascar in 2006 to that in 2009?
Offer a terse response. 0.63. What is the ratio of the Aid flow (current US$) in Malawi in 2006 to that in 2009?
Give a very brief answer. 0.79. What is the ratio of the Aid flow (current US$) in Vanuatu in 2006 to that in 2009?
Provide a short and direct response. 0.33. What is the ratio of the Aid flow (current US$) in Fiji in 2006 to that in 2012?
Give a very brief answer. 0.08. What is the ratio of the Aid flow (current US$) in Madagascar in 2006 to that in 2012?
Offer a terse response. 0.75. What is the ratio of the Aid flow (current US$) of Malawi in 2006 to that in 2012?
Give a very brief answer. 0.51. What is the ratio of the Aid flow (current US$) in Vanuatu in 2006 to that in 2012?
Make the answer very short. 0.08. What is the ratio of the Aid flow (current US$) of Fiji in 2009 to that in 2012?
Your answer should be compact. 0.26. What is the ratio of the Aid flow (current US$) in Madagascar in 2009 to that in 2012?
Give a very brief answer. 1.2. What is the ratio of the Aid flow (current US$) of Malawi in 2009 to that in 2012?
Provide a succinct answer. 0.65. What is the ratio of the Aid flow (current US$) of Vanuatu in 2009 to that in 2012?
Ensure brevity in your answer.  0.25. What is the difference between the highest and the second highest Aid flow (current US$) of Madagascar?
Keep it short and to the point. 8.93e+06. What is the difference between the highest and the second highest Aid flow (current US$) in Malawi?
Your answer should be compact. 4.46e+06. What is the difference between the highest and the second highest Aid flow (current US$) of Vanuatu?
Keep it short and to the point. 0. What is the difference between the highest and the lowest Aid flow (current US$) in Fiji?
Ensure brevity in your answer.  2.52e+06. What is the difference between the highest and the lowest Aid flow (current US$) of Madagascar?
Provide a short and direct response. 1.56e+07. What is the difference between the highest and the lowest Aid flow (current US$) in Malawi?
Keep it short and to the point. 2.73e+07. What is the difference between the highest and the lowest Aid flow (current US$) of Vanuatu?
Provide a succinct answer. 1.10e+05. 